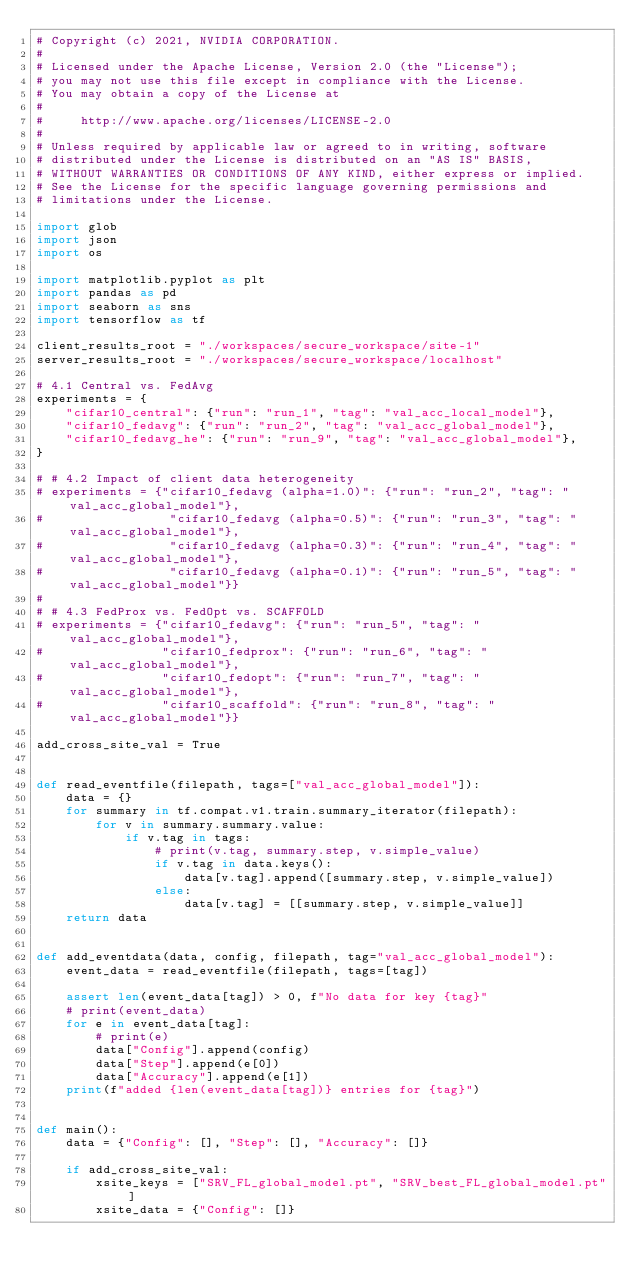Convert code to text. <code><loc_0><loc_0><loc_500><loc_500><_Python_># Copyright (c) 2021, NVIDIA CORPORATION.
#
# Licensed under the Apache License, Version 2.0 (the "License");
# you may not use this file except in compliance with the License.
# You may obtain a copy of the License at
#
#     http://www.apache.org/licenses/LICENSE-2.0
#
# Unless required by applicable law or agreed to in writing, software
# distributed under the License is distributed on an "AS IS" BASIS,
# WITHOUT WARRANTIES OR CONDITIONS OF ANY KIND, either express or implied.
# See the License for the specific language governing permissions and
# limitations under the License.

import glob
import json
import os

import matplotlib.pyplot as plt
import pandas as pd
import seaborn as sns
import tensorflow as tf

client_results_root = "./workspaces/secure_workspace/site-1"
server_results_root = "./workspaces/secure_workspace/localhost"

# 4.1 Central vs. FedAvg
experiments = {
    "cifar10_central": {"run": "run_1", "tag": "val_acc_local_model"},
    "cifar10_fedavg": {"run": "run_2", "tag": "val_acc_global_model"},
    "cifar10_fedavg_he": {"run": "run_9", "tag": "val_acc_global_model"},
}

# # 4.2 Impact of client data heterogeneity
# experiments = {"cifar10_fedavg (alpha=1.0)": {"run": "run_2", "tag": "val_acc_global_model"},
#                 "cifar10_fedavg (alpha=0.5)": {"run": "run_3", "tag": "val_acc_global_model"},
#                 "cifar10_fedavg (alpha=0.3)": {"run": "run_4", "tag": "val_acc_global_model"},
#                 "cifar10_fedavg (alpha=0.1)": {"run": "run_5", "tag": "val_acc_global_model"}}
#
# # 4.3 FedProx vs. FedOpt vs. SCAFFOLD
# experiments = {"cifar10_fedavg": {"run": "run_5", "tag": "val_acc_global_model"},
#                "cifar10_fedprox": {"run": "run_6", "tag": "val_acc_global_model"},
#                "cifar10_fedopt": {"run": "run_7", "tag": "val_acc_global_model"},
#                "cifar10_scaffold": {"run": "run_8", "tag": "val_acc_global_model"}}

add_cross_site_val = True


def read_eventfile(filepath, tags=["val_acc_global_model"]):
    data = {}
    for summary in tf.compat.v1.train.summary_iterator(filepath):
        for v in summary.summary.value:
            if v.tag in tags:
                # print(v.tag, summary.step, v.simple_value)
                if v.tag in data.keys():
                    data[v.tag].append([summary.step, v.simple_value])
                else:
                    data[v.tag] = [[summary.step, v.simple_value]]
    return data


def add_eventdata(data, config, filepath, tag="val_acc_global_model"):
    event_data = read_eventfile(filepath, tags=[tag])

    assert len(event_data[tag]) > 0, f"No data for key {tag}"
    # print(event_data)
    for e in event_data[tag]:
        # print(e)
        data["Config"].append(config)
        data["Step"].append(e[0])
        data["Accuracy"].append(e[1])
    print(f"added {len(event_data[tag])} entries for {tag}")


def main():
    data = {"Config": [], "Step": [], "Accuracy": []}

    if add_cross_site_val:
        xsite_keys = ["SRV_FL_global_model.pt", "SRV_best_FL_global_model.pt"]
        xsite_data = {"Config": []}</code> 